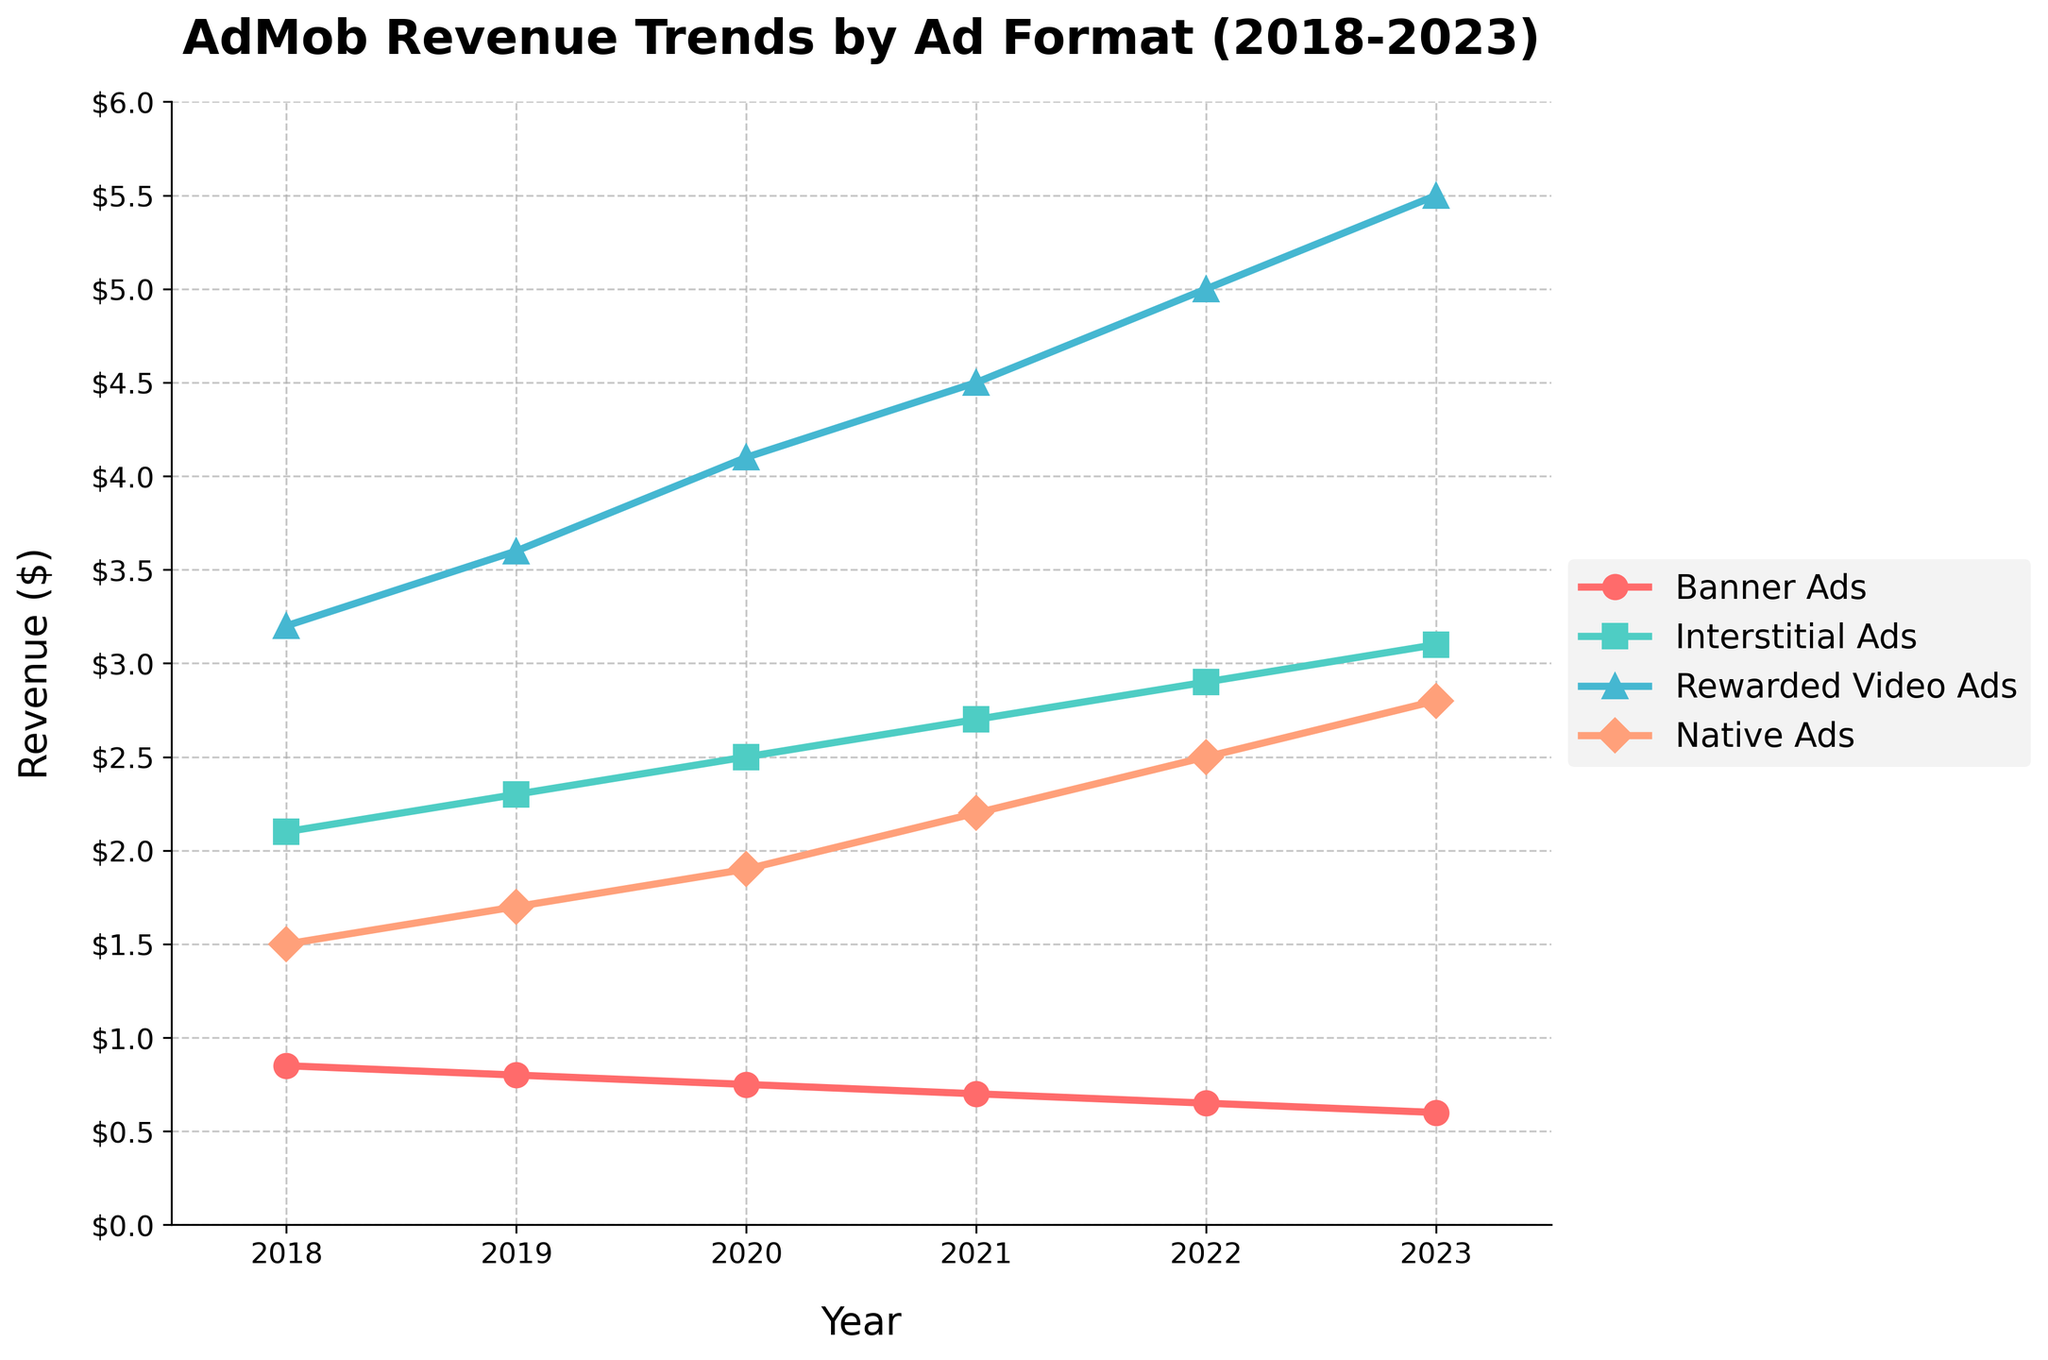What is the revenue trend for Banner Ads from 2018 to 2023? From 2018 to 2023, the revenue for Banner Ads shows a consistent decline each year. The revenue values are 0.85 in 2018, 0.80 in 2019, 0.75 in 2020, 0.70 in 2021, 0.65 in 2022, and 0.60 in 2023. This demonstrates a downward trend.
Answer: Downward trend Which ad format has the highest revenue in 2023? In 2023, the data shows that Rewarded Video Ads have the highest revenue at 5.50. This is higher compared to Banner Ads at 0.60, Interstitial Ads at 3.10, and Native Ads at 2.80.
Answer: Rewarded Video Ads Which year saw the highest revenue for Interstitial Ads? From the data, the Interstitial Ads revenue increases year by year. The highest revenue for Interstitial Ads is in 2023 at 3.10.
Answer: 2023 How does the revenue for Rewarded Video Ads in 2020 compare to that in 2019? The revenue for Rewarded Video Ads in 2020 is 4.10, while in 2019 it is 3.60. By comparing these two values, we see an increase from 2019 to 2020.
Answer: Increase What is the difference in revenue between Native Ads and Interstitial Ads in 2022? In 2022, the revenue for Native Ads is 2.50 and for Interstitial Ads is 2.90. The difference between them is 2.90 - 2.50 = 0.40.
Answer: 0.40 In which year did Banner Ads and Native Ads have the same numerical difference in revenue as in 2018? In 2018, the difference in revenue between Banner Ads (0.85) and Native Ads (1.50) is 1.50 - 0.85 = 0.65. Checking for other years, we see in 2022, the difference between Native Ads (2.50) and Banner Ads (0.65) is 2.50 - 0.65 = 1.85 but none match 0.65, so it appears it does not occur again.
Answer: Does not occur What is the average revenue of Rewarded Video Ads over the 5 years? The revenues for Rewarded Video Ads over the years are 3.20, 3.60, 4.10, 4.50, 5.00, and 5.50. The total sum of these values is 3.20 + 3.60 + 4.10 + 4.50 + 5.00 + 5.50 = 25.90. There are 6 years, so the average is 25.90 / 6 = 4.32.
Answer: 4.32 What is the total revenue for all ad formats in 2021? In 2021, the revenues are Banner Ads: 0.70, Interstitial Ads: 2.70, Rewarded Video Ads: 4.50, Native Ads: 2.20. The total revenue is 0.70 + 2.70 + 4.50 + 2.20 = 10.10.
Answer: 10.10 